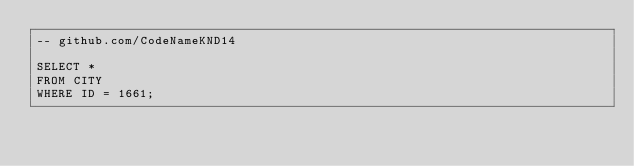<code> <loc_0><loc_0><loc_500><loc_500><_SQL_>-- github.com/CodeNameKND14

SELECT *
FROM CITY 
WHERE ID = 1661;
</code> 